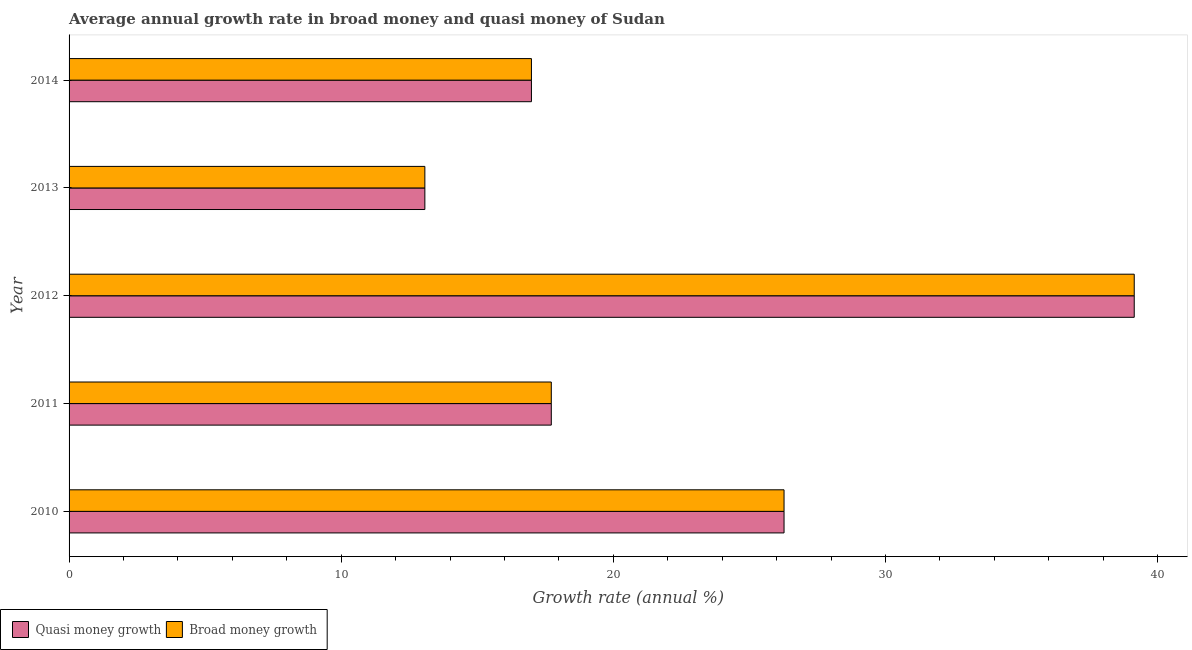How many different coloured bars are there?
Make the answer very short. 2. How many bars are there on the 5th tick from the bottom?
Ensure brevity in your answer.  2. What is the label of the 4th group of bars from the top?
Your response must be concise. 2011. What is the annual growth rate in quasi money in 2012?
Offer a very short reply. 39.14. Across all years, what is the maximum annual growth rate in quasi money?
Provide a succinct answer. 39.14. Across all years, what is the minimum annual growth rate in quasi money?
Ensure brevity in your answer.  13.07. In which year was the annual growth rate in broad money maximum?
Provide a succinct answer. 2012. In which year was the annual growth rate in broad money minimum?
Your answer should be very brief. 2013. What is the total annual growth rate in broad money in the graph?
Your answer should be very brief. 113.2. What is the difference between the annual growth rate in broad money in 2012 and that in 2013?
Make the answer very short. 26.07. What is the difference between the annual growth rate in broad money in 2014 and the annual growth rate in quasi money in 2010?
Your answer should be compact. -9.28. What is the average annual growth rate in quasi money per year?
Provide a short and direct response. 22.64. In how many years, is the annual growth rate in quasi money greater than 8 %?
Give a very brief answer. 5. What is the ratio of the annual growth rate in quasi money in 2013 to that in 2014?
Provide a succinct answer. 0.77. Is the difference between the annual growth rate in broad money in 2010 and 2013 greater than the difference between the annual growth rate in quasi money in 2010 and 2013?
Offer a very short reply. No. What is the difference between the highest and the second highest annual growth rate in quasi money?
Keep it short and to the point. 12.87. What is the difference between the highest and the lowest annual growth rate in quasi money?
Give a very brief answer. 26.07. Is the sum of the annual growth rate in broad money in 2011 and 2014 greater than the maximum annual growth rate in quasi money across all years?
Provide a succinct answer. No. What does the 2nd bar from the top in 2012 represents?
Provide a succinct answer. Quasi money growth. What does the 2nd bar from the bottom in 2011 represents?
Provide a succinct answer. Broad money growth. How many bars are there?
Make the answer very short. 10. Are all the bars in the graph horizontal?
Make the answer very short. Yes. How many years are there in the graph?
Offer a terse response. 5. What is the difference between two consecutive major ticks on the X-axis?
Offer a terse response. 10. Are the values on the major ticks of X-axis written in scientific E-notation?
Keep it short and to the point. No. Does the graph contain grids?
Your answer should be very brief. No. Where does the legend appear in the graph?
Your answer should be very brief. Bottom left. How many legend labels are there?
Keep it short and to the point. 2. What is the title of the graph?
Provide a succinct answer. Average annual growth rate in broad money and quasi money of Sudan. Does "Forest land" appear as one of the legend labels in the graph?
Give a very brief answer. No. What is the label or title of the X-axis?
Provide a succinct answer. Growth rate (annual %). What is the Growth rate (annual %) in Quasi money growth in 2010?
Offer a terse response. 26.27. What is the Growth rate (annual %) of Broad money growth in 2010?
Provide a succinct answer. 26.27. What is the Growth rate (annual %) in Quasi money growth in 2011?
Your answer should be compact. 17.72. What is the Growth rate (annual %) in Broad money growth in 2011?
Ensure brevity in your answer.  17.72. What is the Growth rate (annual %) of Quasi money growth in 2012?
Your answer should be very brief. 39.14. What is the Growth rate (annual %) of Broad money growth in 2012?
Your answer should be very brief. 39.14. What is the Growth rate (annual %) in Quasi money growth in 2013?
Keep it short and to the point. 13.07. What is the Growth rate (annual %) in Broad money growth in 2013?
Your response must be concise. 13.07. What is the Growth rate (annual %) in Quasi money growth in 2014?
Make the answer very short. 16.99. What is the Growth rate (annual %) in Broad money growth in 2014?
Your answer should be compact. 16.99. Across all years, what is the maximum Growth rate (annual %) in Quasi money growth?
Keep it short and to the point. 39.14. Across all years, what is the maximum Growth rate (annual %) of Broad money growth?
Offer a terse response. 39.14. Across all years, what is the minimum Growth rate (annual %) of Quasi money growth?
Your answer should be very brief. 13.07. Across all years, what is the minimum Growth rate (annual %) of Broad money growth?
Offer a very short reply. 13.07. What is the total Growth rate (annual %) in Quasi money growth in the graph?
Your answer should be compact. 113.2. What is the total Growth rate (annual %) of Broad money growth in the graph?
Offer a very short reply. 113.2. What is the difference between the Growth rate (annual %) of Quasi money growth in 2010 and that in 2011?
Keep it short and to the point. 8.55. What is the difference between the Growth rate (annual %) in Broad money growth in 2010 and that in 2011?
Make the answer very short. 8.55. What is the difference between the Growth rate (annual %) of Quasi money growth in 2010 and that in 2012?
Keep it short and to the point. -12.87. What is the difference between the Growth rate (annual %) of Broad money growth in 2010 and that in 2012?
Make the answer very short. -12.87. What is the difference between the Growth rate (annual %) of Quasi money growth in 2010 and that in 2013?
Your answer should be compact. 13.2. What is the difference between the Growth rate (annual %) in Broad money growth in 2010 and that in 2013?
Make the answer very short. 13.2. What is the difference between the Growth rate (annual %) in Quasi money growth in 2010 and that in 2014?
Ensure brevity in your answer.  9.28. What is the difference between the Growth rate (annual %) of Broad money growth in 2010 and that in 2014?
Ensure brevity in your answer.  9.28. What is the difference between the Growth rate (annual %) in Quasi money growth in 2011 and that in 2012?
Your response must be concise. -21.42. What is the difference between the Growth rate (annual %) in Broad money growth in 2011 and that in 2012?
Offer a terse response. -21.42. What is the difference between the Growth rate (annual %) of Quasi money growth in 2011 and that in 2013?
Offer a very short reply. 4.65. What is the difference between the Growth rate (annual %) of Broad money growth in 2011 and that in 2013?
Keep it short and to the point. 4.65. What is the difference between the Growth rate (annual %) of Quasi money growth in 2011 and that in 2014?
Offer a terse response. 0.73. What is the difference between the Growth rate (annual %) in Broad money growth in 2011 and that in 2014?
Ensure brevity in your answer.  0.73. What is the difference between the Growth rate (annual %) in Quasi money growth in 2012 and that in 2013?
Make the answer very short. 26.07. What is the difference between the Growth rate (annual %) in Broad money growth in 2012 and that in 2013?
Ensure brevity in your answer.  26.07. What is the difference between the Growth rate (annual %) of Quasi money growth in 2012 and that in 2014?
Your response must be concise. 22.15. What is the difference between the Growth rate (annual %) of Broad money growth in 2012 and that in 2014?
Your response must be concise. 22.15. What is the difference between the Growth rate (annual %) of Quasi money growth in 2013 and that in 2014?
Give a very brief answer. -3.92. What is the difference between the Growth rate (annual %) in Broad money growth in 2013 and that in 2014?
Make the answer very short. -3.92. What is the difference between the Growth rate (annual %) of Quasi money growth in 2010 and the Growth rate (annual %) of Broad money growth in 2011?
Your answer should be compact. 8.55. What is the difference between the Growth rate (annual %) in Quasi money growth in 2010 and the Growth rate (annual %) in Broad money growth in 2012?
Keep it short and to the point. -12.87. What is the difference between the Growth rate (annual %) in Quasi money growth in 2010 and the Growth rate (annual %) in Broad money growth in 2013?
Your response must be concise. 13.2. What is the difference between the Growth rate (annual %) in Quasi money growth in 2010 and the Growth rate (annual %) in Broad money growth in 2014?
Your answer should be compact. 9.28. What is the difference between the Growth rate (annual %) in Quasi money growth in 2011 and the Growth rate (annual %) in Broad money growth in 2012?
Provide a short and direct response. -21.42. What is the difference between the Growth rate (annual %) in Quasi money growth in 2011 and the Growth rate (annual %) in Broad money growth in 2013?
Make the answer very short. 4.65. What is the difference between the Growth rate (annual %) in Quasi money growth in 2011 and the Growth rate (annual %) in Broad money growth in 2014?
Make the answer very short. 0.73. What is the difference between the Growth rate (annual %) of Quasi money growth in 2012 and the Growth rate (annual %) of Broad money growth in 2013?
Your answer should be very brief. 26.07. What is the difference between the Growth rate (annual %) in Quasi money growth in 2012 and the Growth rate (annual %) in Broad money growth in 2014?
Your response must be concise. 22.15. What is the difference between the Growth rate (annual %) in Quasi money growth in 2013 and the Growth rate (annual %) in Broad money growth in 2014?
Give a very brief answer. -3.92. What is the average Growth rate (annual %) of Quasi money growth per year?
Your response must be concise. 22.64. What is the average Growth rate (annual %) in Broad money growth per year?
Ensure brevity in your answer.  22.64. In the year 2011, what is the difference between the Growth rate (annual %) of Quasi money growth and Growth rate (annual %) of Broad money growth?
Offer a very short reply. 0. In the year 2013, what is the difference between the Growth rate (annual %) in Quasi money growth and Growth rate (annual %) in Broad money growth?
Offer a terse response. 0. What is the ratio of the Growth rate (annual %) in Quasi money growth in 2010 to that in 2011?
Make the answer very short. 1.48. What is the ratio of the Growth rate (annual %) in Broad money growth in 2010 to that in 2011?
Keep it short and to the point. 1.48. What is the ratio of the Growth rate (annual %) in Quasi money growth in 2010 to that in 2012?
Ensure brevity in your answer.  0.67. What is the ratio of the Growth rate (annual %) of Broad money growth in 2010 to that in 2012?
Offer a very short reply. 0.67. What is the ratio of the Growth rate (annual %) in Quasi money growth in 2010 to that in 2013?
Provide a short and direct response. 2.01. What is the ratio of the Growth rate (annual %) in Broad money growth in 2010 to that in 2013?
Provide a short and direct response. 2.01. What is the ratio of the Growth rate (annual %) of Quasi money growth in 2010 to that in 2014?
Offer a very short reply. 1.55. What is the ratio of the Growth rate (annual %) of Broad money growth in 2010 to that in 2014?
Give a very brief answer. 1.55. What is the ratio of the Growth rate (annual %) of Quasi money growth in 2011 to that in 2012?
Your response must be concise. 0.45. What is the ratio of the Growth rate (annual %) of Broad money growth in 2011 to that in 2012?
Offer a terse response. 0.45. What is the ratio of the Growth rate (annual %) of Quasi money growth in 2011 to that in 2013?
Make the answer very short. 1.36. What is the ratio of the Growth rate (annual %) in Broad money growth in 2011 to that in 2013?
Keep it short and to the point. 1.36. What is the ratio of the Growth rate (annual %) of Quasi money growth in 2011 to that in 2014?
Provide a short and direct response. 1.04. What is the ratio of the Growth rate (annual %) of Broad money growth in 2011 to that in 2014?
Provide a succinct answer. 1.04. What is the ratio of the Growth rate (annual %) of Quasi money growth in 2012 to that in 2013?
Ensure brevity in your answer.  2.99. What is the ratio of the Growth rate (annual %) of Broad money growth in 2012 to that in 2013?
Provide a short and direct response. 2.99. What is the ratio of the Growth rate (annual %) of Quasi money growth in 2012 to that in 2014?
Keep it short and to the point. 2.3. What is the ratio of the Growth rate (annual %) of Broad money growth in 2012 to that in 2014?
Make the answer very short. 2.3. What is the ratio of the Growth rate (annual %) of Quasi money growth in 2013 to that in 2014?
Ensure brevity in your answer.  0.77. What is the ratio of the Growth rate (annual %) of Broad money growth in 2013 to that in 2014?
Provide a short and direct response. 0.77. What is the difference between the highest and the second highest Growth rate (annual %) of Quasi money growth?
Give a very brief answer. 12.87. What is the difference between the highest and the second highest Growth rate (annual %) of Broad money growth?
Keep it short and to the point. 12.87. What is the difference between the highest and the lowest Growth rate (annual %) of Quasi money growth?
Make the answer very short. 26.07. What is the difference between the highest and the lowest Growth rate (annual %) in Broad money growth?
Ensure brevity in your answer.  26.07. 